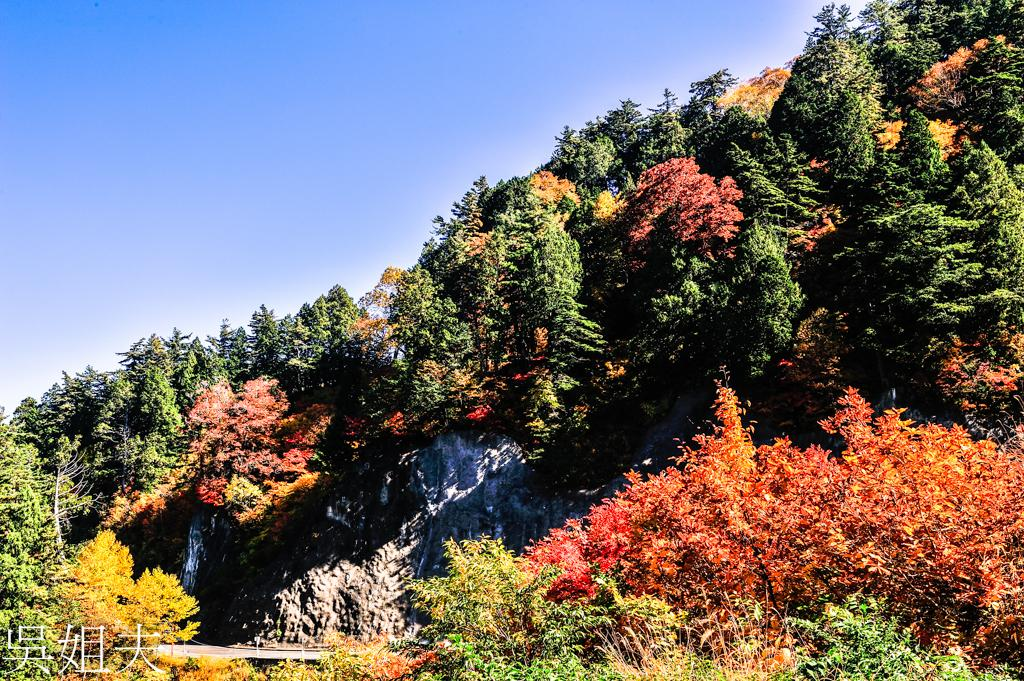What type of vegetation can be seen in the image? There are trees in the image. What other natural elements are present in the image? There are rocks in the image. What is visible in the background of the image? The sky is visible in the image. How many frogs are sitting on the rocks in the image? There are no frogs present in the image; it only features trees, rocks, and the sky. What type of kite can be seen flying in the sky in the image? There is no kite visible in the sky in the image; only the sky itself is present. 